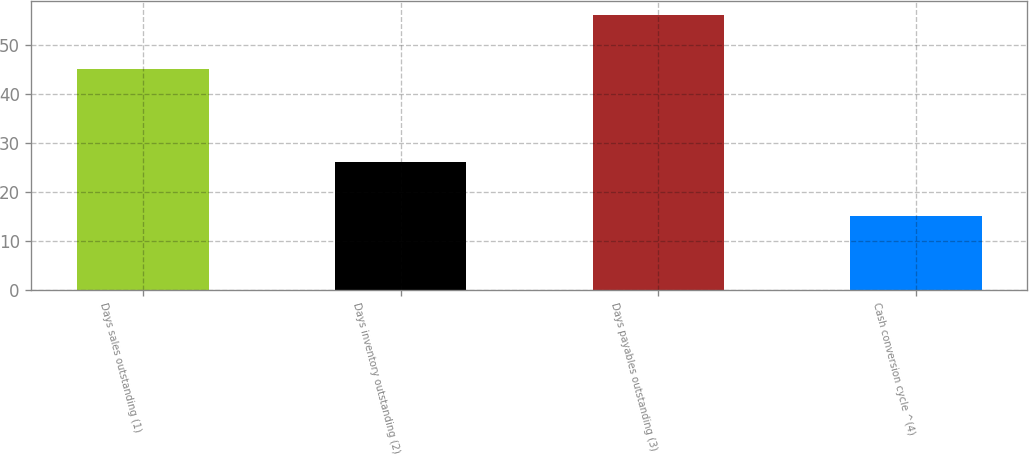Convert chart. <chart><loc_0><loc_0><loc_500><loc_500><bar_chart><fcel>Days sales outstanding (1)<fcel>Days inventory outstanding (2)<fcel>Days payables outstanding (3)<fcel>Cash conversion cycle ^(4)<nl><fcel>45<fcel>26<fcel>56<fcel>15<nl></chart> 